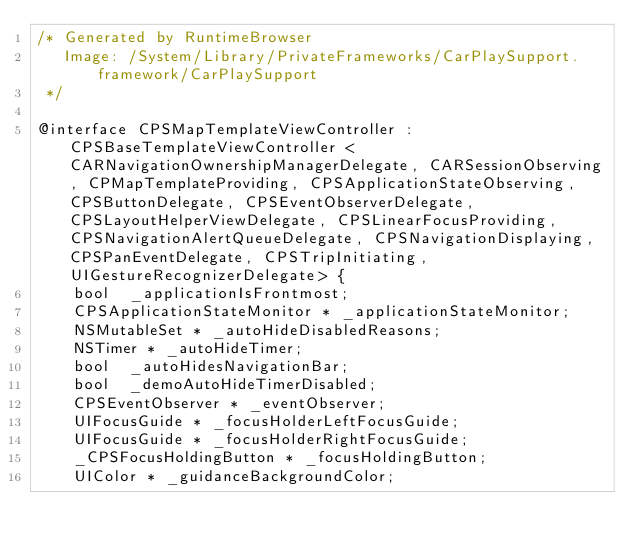Convert code to text. <code><loc_0><loc_0><loc_500><loc_500><_C_>/* Generated by RuntimeBrowser
   Image: /System/Library/PrivateFrameworks/CarPlaySupport.framework/CarPlaySupport
 */

@interface CPSMapTemplateViewController : CPSBaseTemplateViewController <CARNavigationOwnershipManagerDelegate, CARSessionObserving, CPMapTemplateProviding, CPSApplicationStateObserving, CPSButtonDelegate, CPSEventObserverDelegate, CPSLayoutHelperViewDelegate, CPSLinearFocusProviding, CPSNavigationAlertQueueDelegate, CPSNavigationDisplaying, CPSPanEventDelegate, CPSTripInitiating, UIGestureRecognizerDelegate> {
    bool  _applicationIsFrontmost;
    CPSApplicationStateMonitor * _applicationStateMonitor;
    NSMutableSet * _autoHideDisabledReasons;
    NSTimer * _autoHideTimer;
    bool  _autoHidesNavigationBar;
    bool  _demoAutoHideTimerDisabled;
    CPSEventObserver * _eventObserver;
    UIFocusGuide * _focusHolderLeftFocusGuide;
    UIFocusGuide * _focusHolderRightFocusGuide;
    _CPSFocusHoldingButton * _focusHoldingButton;
    UIColor * _guidanceBackgroundColor;</code> 